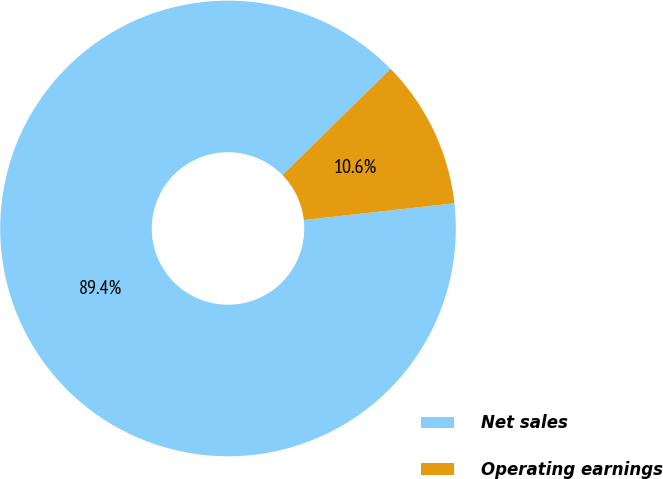Convert chart. <chart><loc_0><loc_0><loc_500><loc_500><pie_chart><fcel>Net sales<fcel>Operating earnings<nl><fcel>89.41%<fcel>10.59%<nl></chart> 